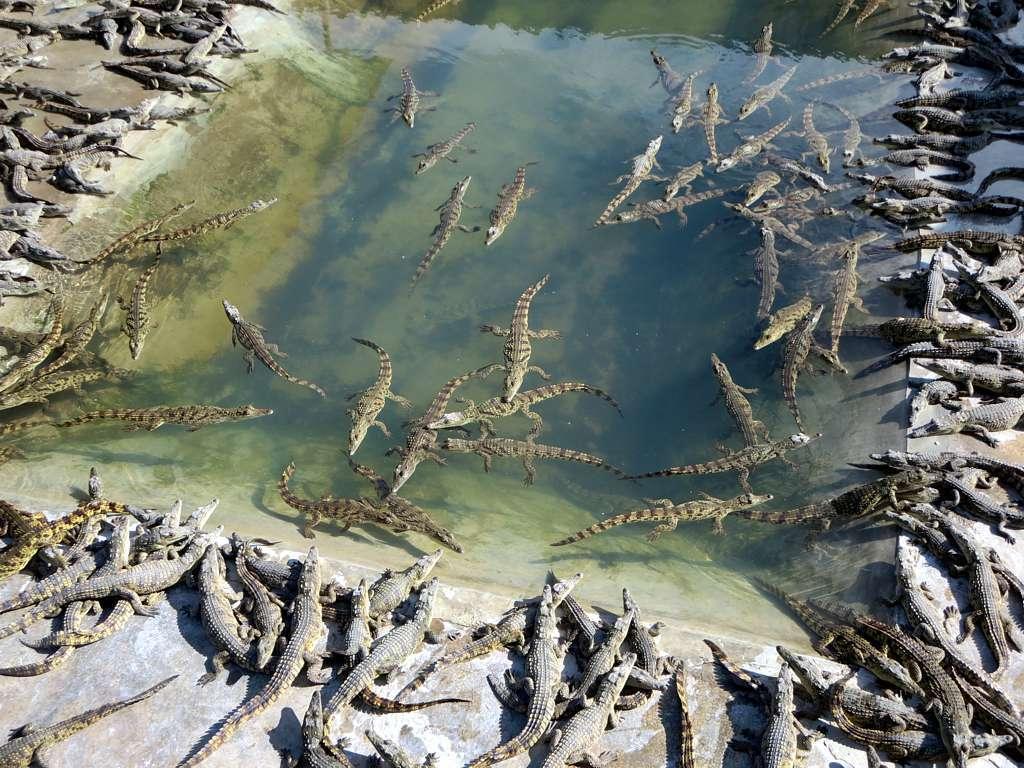Describe this image in one or two sentences. In this image we can see crocodiles in water and land. 